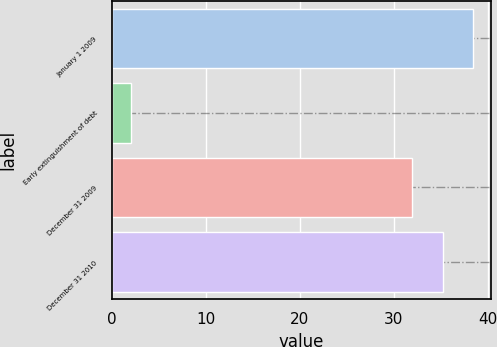Convert chart to OTSL. <chart><loc_0><loc_0><loc_500><loc_500><bar_chart><fcel>January 1 2009<fcel>Early extinguishment of debt<fcel>December 31 2009<fcel>December 31 2010<nl><fcel>38.4<fcel>2<fcel>32<fcel>35.2<nl></chart> 